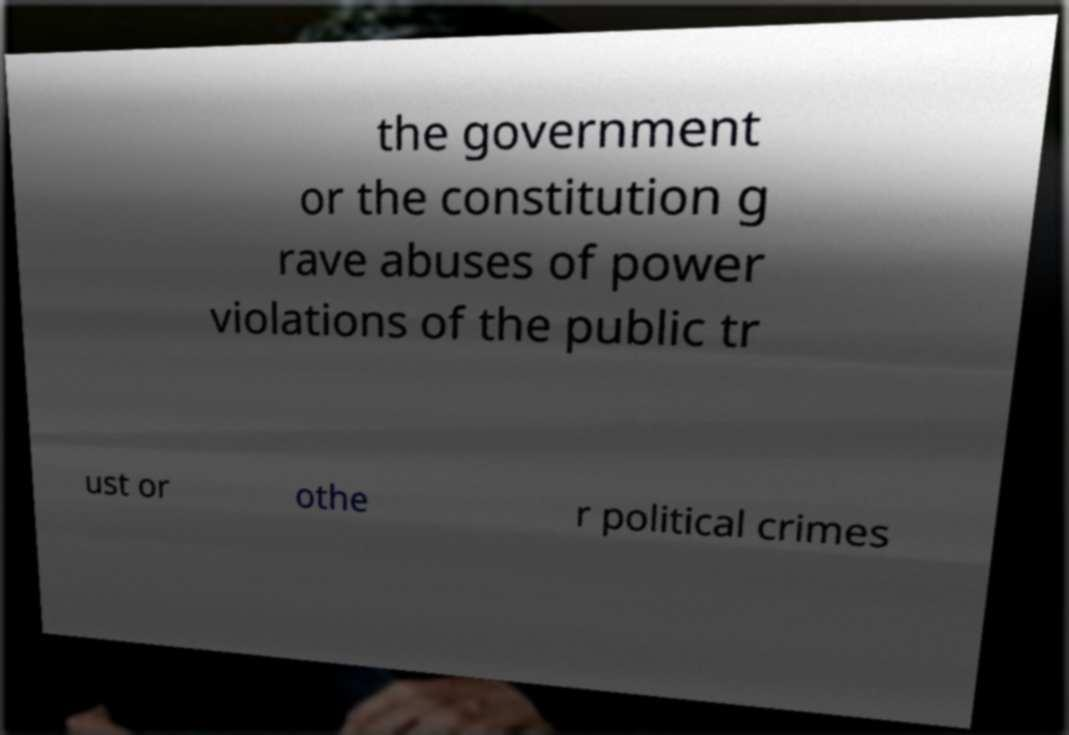Can you accurately transcribe the text from the provided image for me? the government or the constitution g rave abuses of power violations of the public tr ust or othe r political crimes 